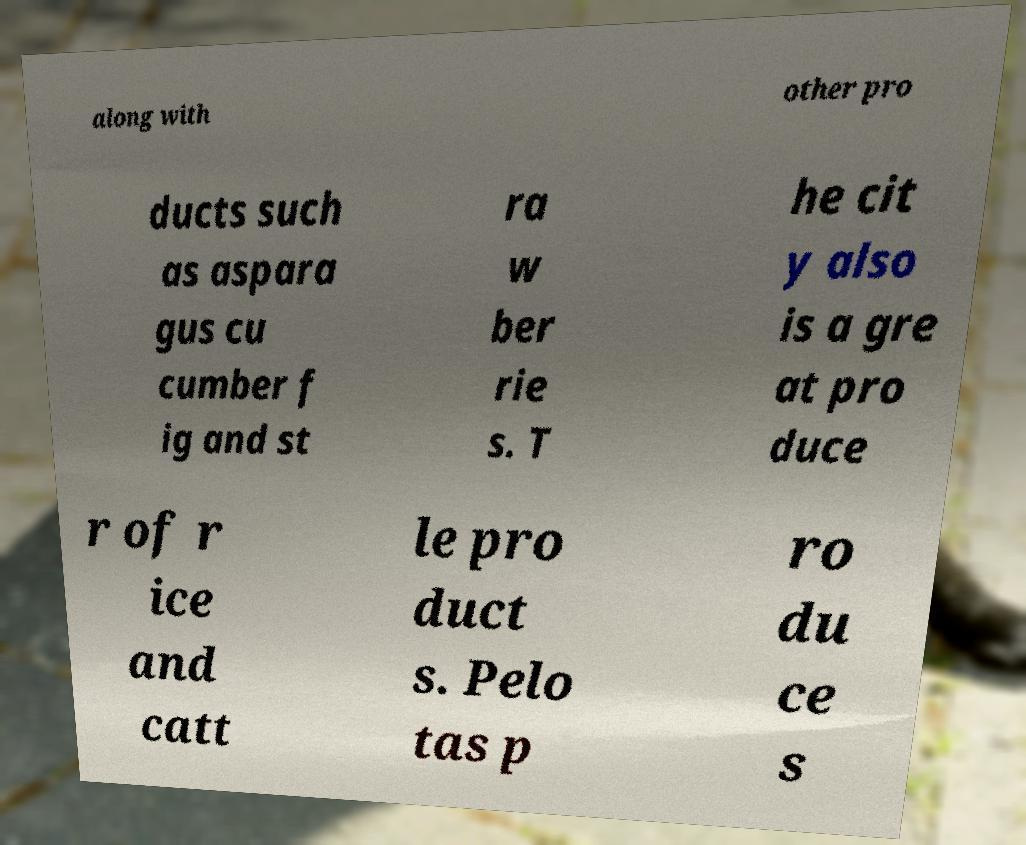Please read and relay the text visible in this image. What does it say? along with other pro ducts such as aspara gus cu cumber f ig and st ra w ber rie s. T he cit y also is a gre at pro duce r of r ice and catt le pro duct s. Pelo tas p ro du ce s 